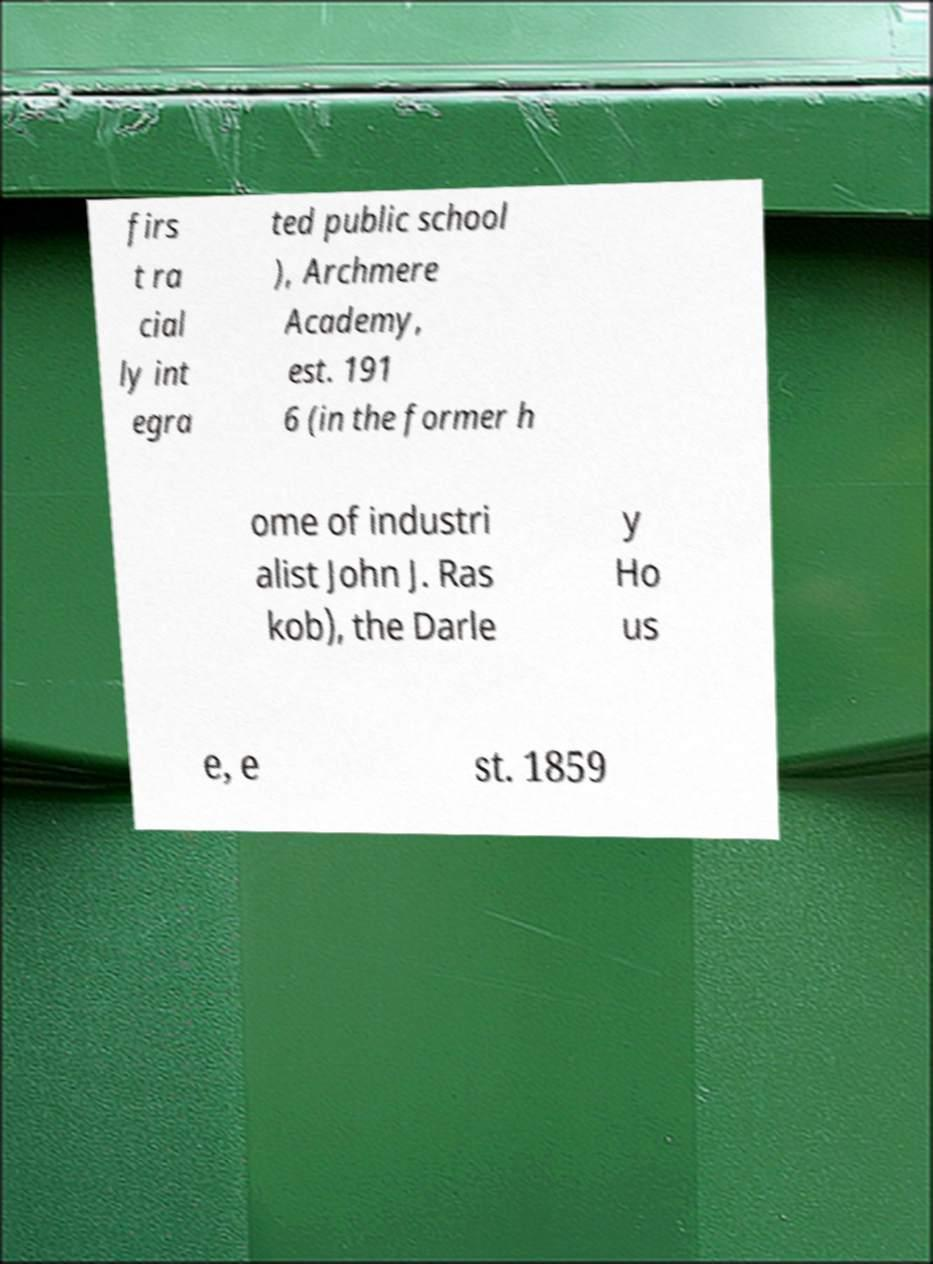Could you assist in decoding the text presented in this image and type it out clearly? firs t ra cial ly int egra ted public school ), Archmere Academy, est. 191 6 (in the former h ome of industri alist John J. Ras kob), the Darle y Ho us e, e st. 1859 